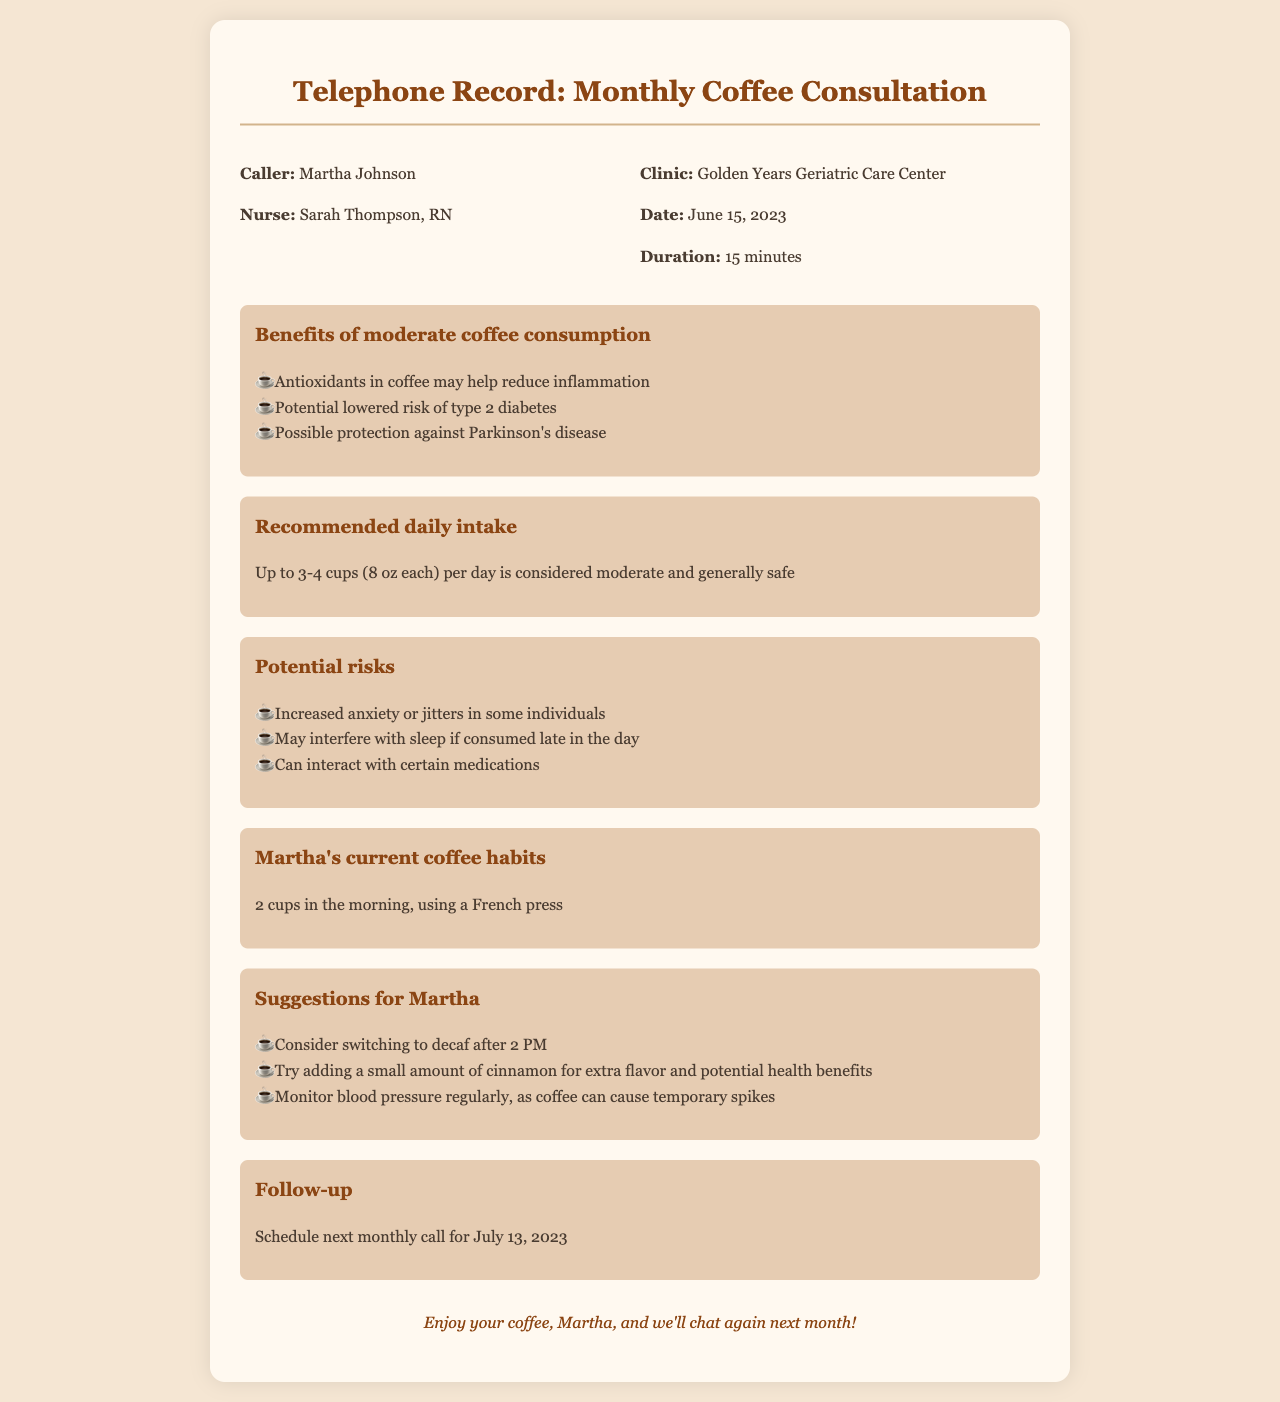What is the name of the caller? The caller is identified at the beginning of the document as Martha Johnson.
Answer: Martha Johnson Who is the nurse that Martha consults with? The nurse's name is provided in the header of the document as Sarah Thompson.
Answer: Sarah Thompson What is the date of the consultation? The date of the consultation is clearly stated in the header section of the document as June 15, 2023.
Answer: June 15, 2023 How long did the consultation last? The duration of the consultation is mentioned in the header section as 15 minutes.
Answer: 15 minutes What is the recommended daily intake of coffee stated in the document? The document specifies that up to 3-4 cups per day is considered moderate.
Answer: Up to 3-4 cups What are potential risks associated with coffee consumption mentioned in the document? The document lists several risks, including increased anxiety or jitters and may interfere with sleep.
Answer: Increased anxiety or jitters What does Martha drink in the morning? Martha's coffee habit is described in the document, indicating she drinks 2 cups in the morning.
Answer: 2 cups What suggestion was given to Martha regarding coffee after 2 PM? The document suggests that Martha consider switching to decaf after 2 PM.
Answer: Switch to decaf When is the next monthly call scheduled? The follow-up section of the document mentions that the next call is scheduled for July 13, 2023.
Answer: July 13, 2023 